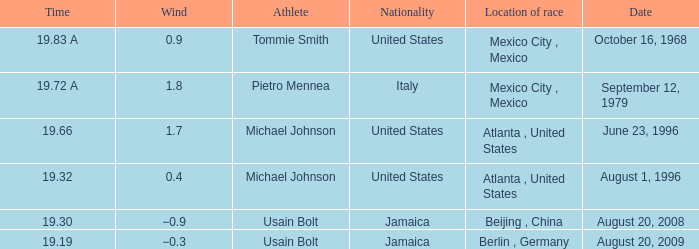Who's the competitor with a wind of Michael Johnson. 